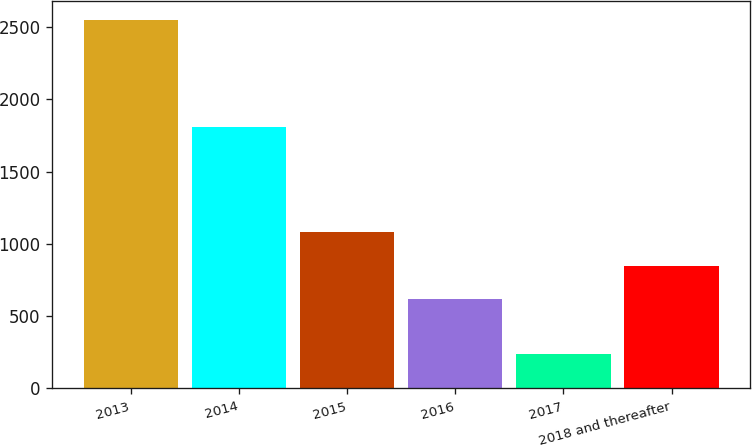<chart> <loc_0><loc_0><loc_500><loc_500><bar_chart><fcel>2013<fcel>2014<fcel>2015<fcel>2016<fcel>2017<fcel>2018 and thereafter<nl><fcel>2552<fcel>1809<fcel>1081<fcel>618<fcel>237<fcel>849.5<nl></chart> 